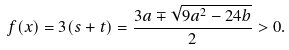<formula> <loc_0><loc_0><loc_500><loc_500>f ( x ) = 3 ( s + t ) = \frac { 3 a \mp \sqrt { 9 a ^ { 2 } - 2 4 b } } { 2 } > 0 .</formula> 